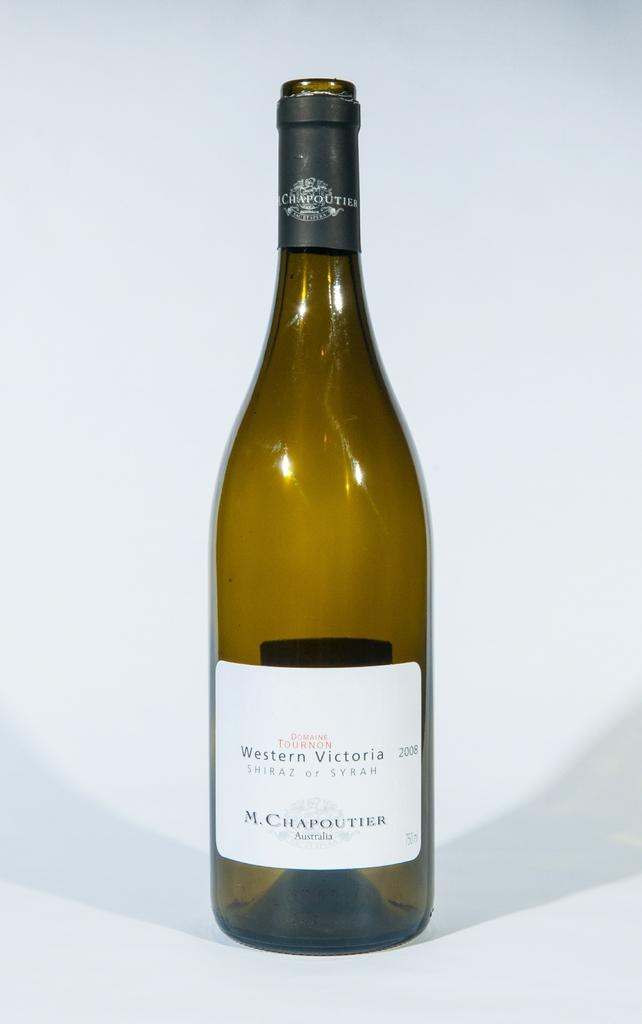<image>
Give a short and clear explanation of the subsequent image. An empty bottle of Syrah from Western Victoria. 